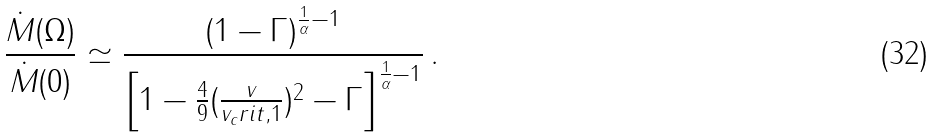Convert formula to latex. <formula><loc_0><loc_0><loc_500><loc_500>\frac { \dot { M } ( \Omega ) } { \dot { M } ( 0 ) } \simeq \frac { \left ( 1 - \Gamma \right ) ^ { \frac { 1 } { \alpha } - 1 } } { \left [ 1 - \frac { 4 } { 9 } ( \frac { v } { v _ { c } r i t , 1 } ) ^ { 2 } - \Gamma \right ] ^ { \frac { 1 } { \alpha } - 1 } } \, .</formula> 